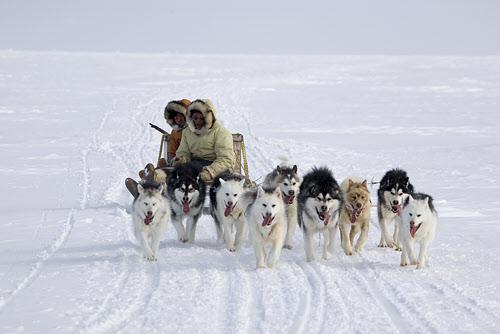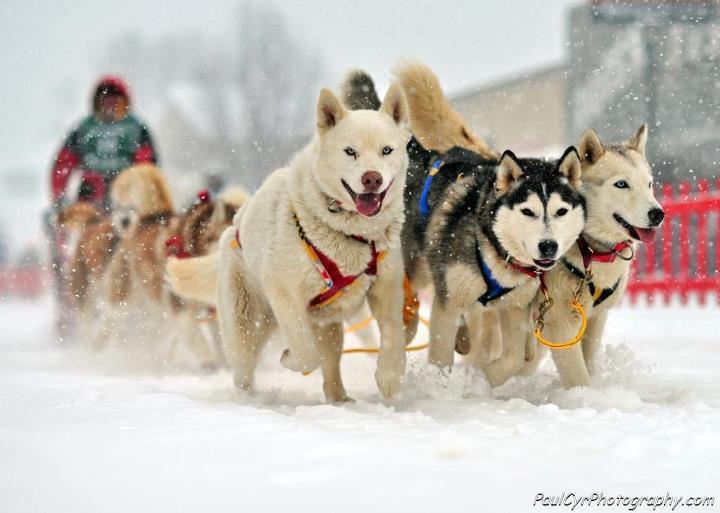The first image is the image on the left, the second image is the image on the right. Analyze the images presented: Is the assertion "The right image contains no more than three dogs." valid? Answer yes or no. No. 